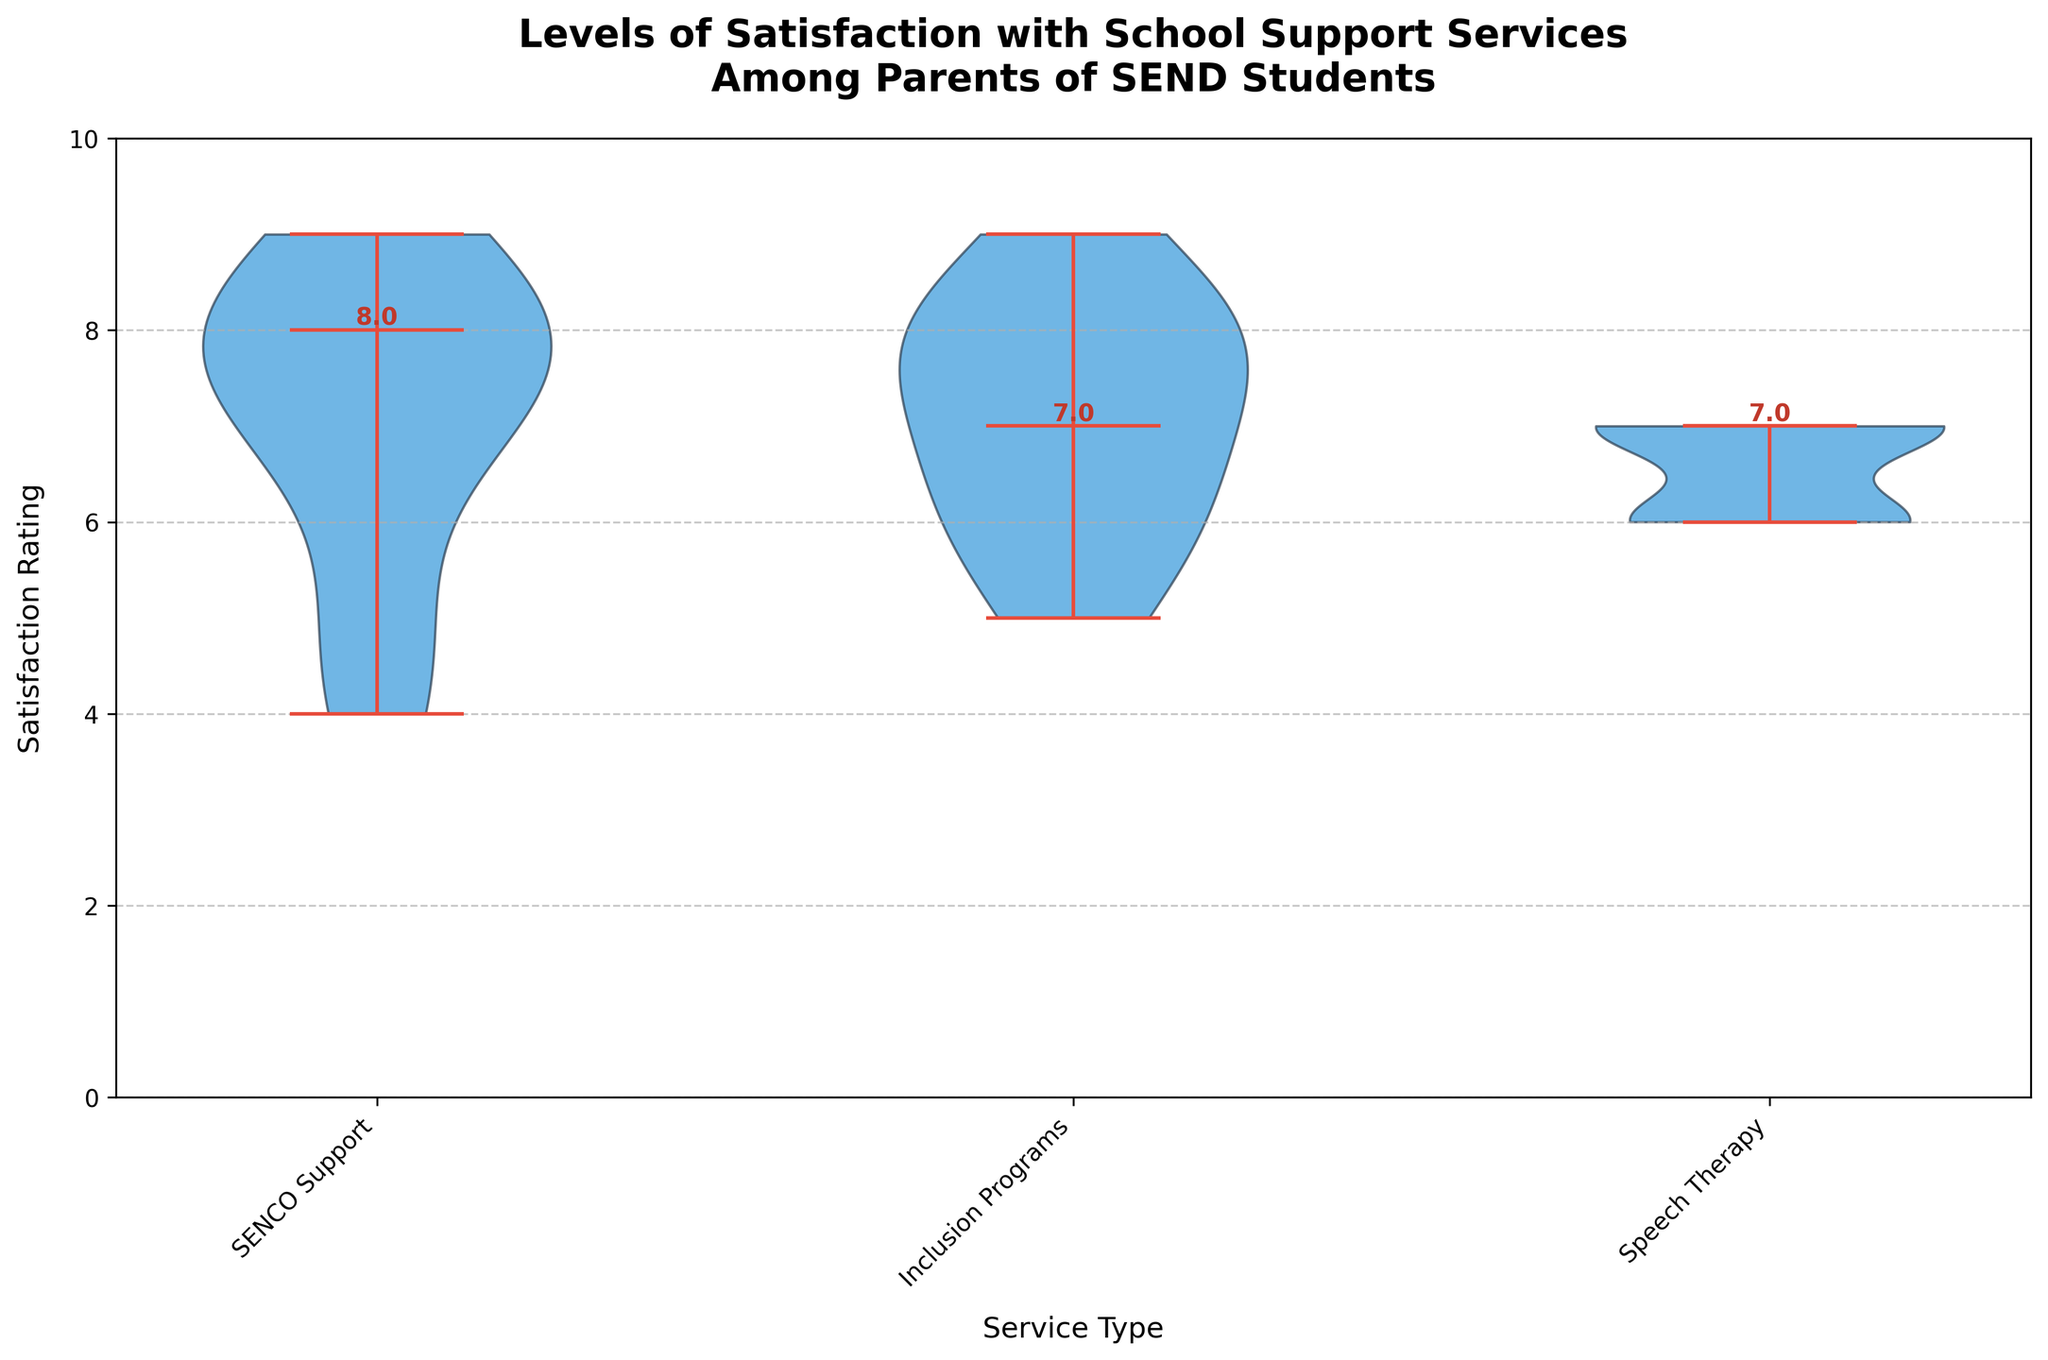What's the title of the chart? The title of the chart is located at the top and provides an overview of what the chart represents.
Answer: Levels of Satisfaction with School Support Services Among Parents of SEND Students What is the median rating for SENCO Support? The median rating is indicated by the horizontal line inside the violin plot for SENCO Support.
Answer: 7.0 Which service has the highest median satisfaction rating? By looking at the position of the median lines, the service with the highest median satisfaction rating can be identified.
Answer: Inclusion Programs How does the satisfaction rating for SENCO Support in 2022 at Wingfield Academy compare to 2021? By comparing the median lines for SENCO Support at Wingfield Academy in 2021 and 2022, the change in satisfaction can be observed.
Answer: The rating decreased in 2022 What is the range of ratings for Speech Therapy? The spread of the violin plot from top to bottom shows the range of ratings.
Answer: 6 to 7 Which service at Wingfield Academy in 2021 had the lowest satisfaction rating? By observing the individual data points within the violin plot for Wingfield Academy in 2021, the service with the lowest rating can be identified.
Answer: Speech Therapy Is there a noticeable difference in satisfaction for SENCO Support between the schools? By comparing the median lines and overall distribution of the SENCO Support plots for different schools, one can determine if there is noticeable variability.
Answer: Yes What does the color of the violin plots represent? The consistent color across the violin plots signifies a uniform dataset representation without differing color codes for different elements.
Answer: Satisfaction ratings Which school shows the greatest improvement in satisfaction for Inclusion Programs from 2021 to 2022? By comparing the median lines for Inclusion Programs between 2021 and 2022 for each school, the school with the greatest improvement can be identified.
Answer: Lakewood High Is Speech Therapy consistently rated similar across the different schools? By comparing the median lines and distributions for Speech Therapy across different schools, the consistency of ratings can be evaluated.
Answer: Yes 